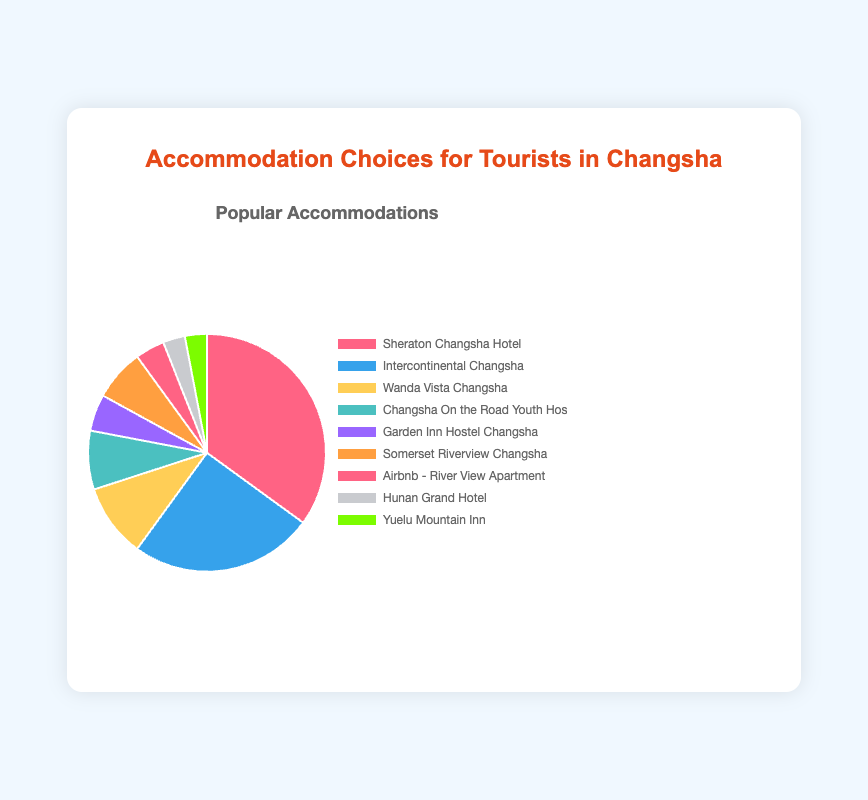What is the total percentage of tourists staying in hotels? Sum the percentages of tourists staying in Sheraton Changsha Hotel (35%), Intercontinental Changsha (25%), and Wanda Vista Changsha (10%). So, 35% + 25% + 10% = 70%.
Answer: 70% Which accommodation option has the least percentage of tourists? Compare the percentages of all options. The options with the smallest percentage are Hunan Grand Hotel and Yuelu Mountain Inn, each with 3%.
Answer: Hunan Grand Hotel and Yuelu Mountain Inn Which accommodation type is the most popular among tourists? Identify the accommodation type with the highest percentage. Hotels collectively have the highest percentage with a sum of 35% + 25% + 10% = 70%.
Answer: Hotels How do the percentages of hostels compare? Compare the percentages of Changsha On the Road Youth Hostel (8%) and Garden Inn Hostel Changsha (5%). 8% is greater than 5%.
Answer: Changsha On the Road Youth Hostel has a higher percentage What is the combined percentage of tourists staying in accommodation types other than hotels? Sum the percentages of accommodation types other than Hotels: 8% (Changsha On the Road Youth Hostel) + 5% (Garden Inn Hostel Changsha) + 7% (Somerset Riverview Changsha) + 4% (Airbnb - River View Apartment) + 3% (Hunan Grand Hotel) + 3% (Yuelu Mountain Inn). So, 8% + 5% + 7% + 4% + 3% + 3% = 30%.
Answer: 30% Which is more popular: apartments or vacation rentals? Compare the percentages of Somerset Riverview Changsha (7%) with Airbnb - River View Apartment (4%). 7% is greater than 4%.
Answer: Apartments (Somerset Riverview Changsha) What is the visual difference in color between the type represented by the red slice and the blue slice? Identify the slices represented by red and blue. Sheraton Changsha Hotel is in red and Intercontinental Changsha is in blue. The visual difference is the distinct colors used.
Answer: Red is for Sheraton Changsha Hotel; blue is for Intercontinental Changsha How much more popular is the most preferred accommodation compared to the least preferred one? Identify the most preferred accommodation (Sheraton Changsha Hotel at 35%) and the least preferred (both Hunan Grand Hotel and Yuelu Mountain Inn at 3%). The difference is 35% - 3% = 32%.
Answer: 32% What percentage of tourists stay in boutique hotels and bed and breakfasts combined? Add the percentages of tourists staying in Hunan Grand Hotel (3%) and Yuelu Mountain Inn (3%). So, 3% + 3% = 6%.
Answer: 6% 